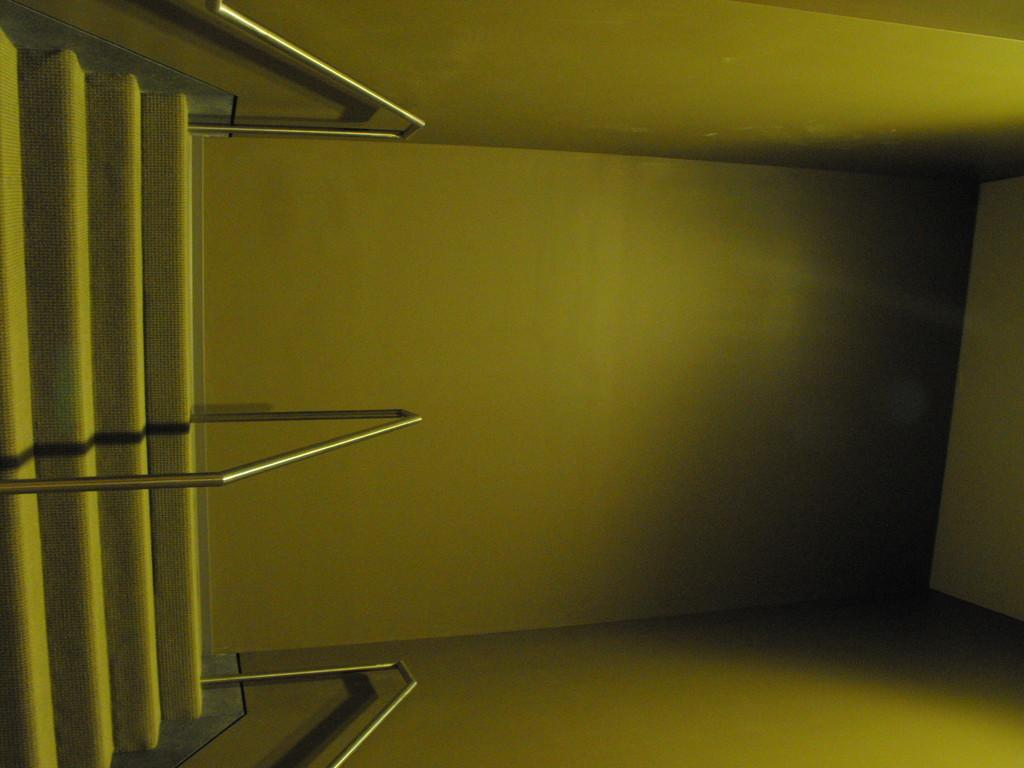What type of structure is located on the left side of the image? There are stairs on the left side of the image. What feature can be seen on the stairs? There are rod railings on the stairs. What else is visible in the image besides the stairs and railings? Walls are visible in the image. How many snakes are slithering on the walls in the image? There are no snakes present in the image; only stairs, rod railings, and walls are visible. 